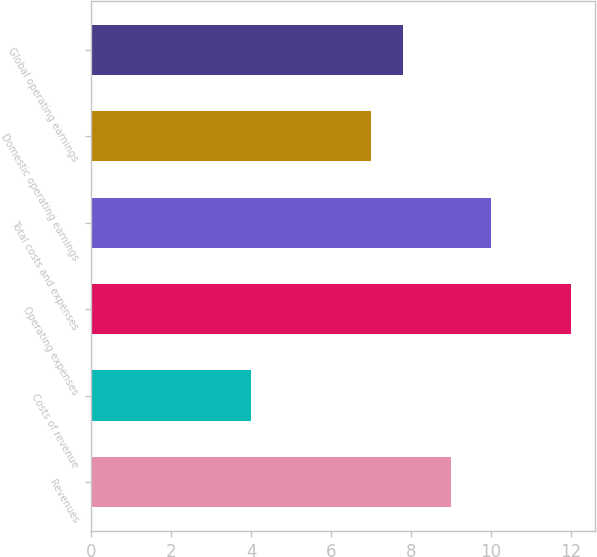<chart> <loc_0><loc_0><loc_500><loc_500><bar_chart><fcel>Revenues<fcel>Costs of revenue<fcel>Operating expenses<fcel>Total costs and expenses<fcel>Domestic operating earnings<fcel>Global operating earnings<nl><fcel>9<fcel>4<fcel>12<fcel>10<fcel>7<fcel>7.8<nl></chart> 